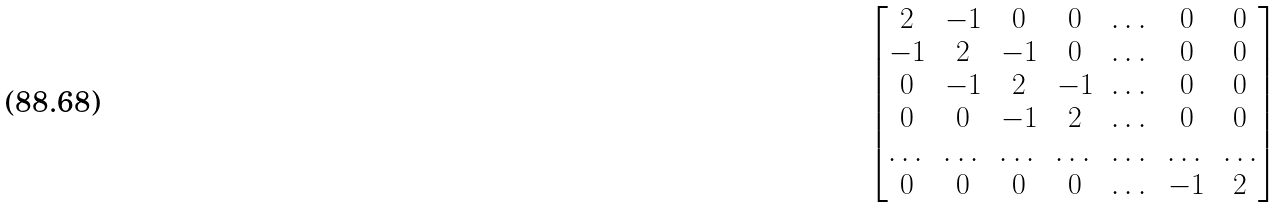<formula> <loc_0><loc_0><loc_500><loc_500>\begin{bmatrix} 2 & - 1 & 0 & 0 & \dots & 0 & 0 \\ - 1 & 2 & - 1 & 0 & \dots & 0 & 0 \\ 0 & - 1 & 2 & - 1 & \dots & 0 & 0 \\ 0 & 0 & - 1 & 2 & \dots & 0 & 0 \\ \dots & \dots & \dots & \dots & \dots & \dots & \dots \\ 0 & 0 & 0 & 0 & \dots & - 1 & 2 \\ \end{bmatrix}</formula> 